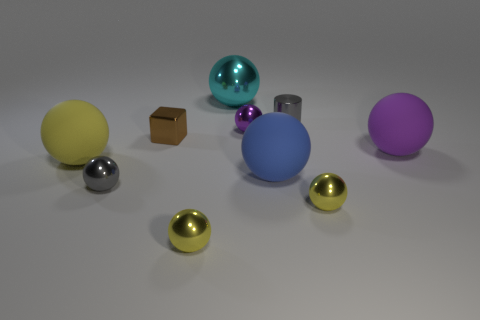How many purple balls must be subtracted to get 1 purple balls? 1 Subtract all large yellow balls. How many balls are left? 7 Subtract all cylinders. How many objects are left? 9 Subtract all yellow balls. How many balls are left? 5 Subtract 0 brown cylinders. How many objects are left? 10 Subtract 1 cubes. How many cubes are left? 0 Subtract all brown balls. Subtract all yellow cubes. How many balls are left? 8 Subtract all purple cylinders. How many blue balls are left? 1 Subtract all big red metal cubes. Subtract all big yellow objects. How many objects are left? 9 Add 6 large blue matte objects. How many large blue matte objects are left? 7 